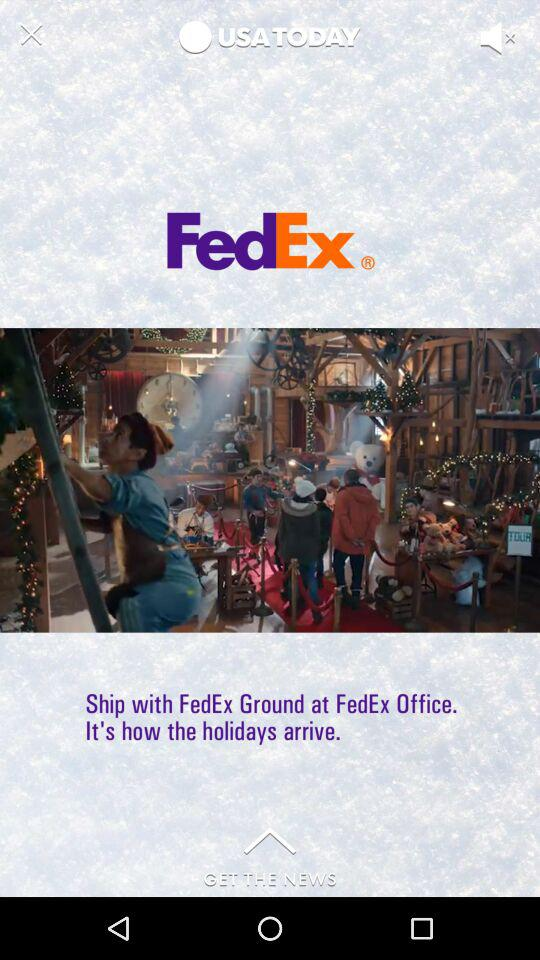What is the name of the application? The name of the application is "FedEx". 